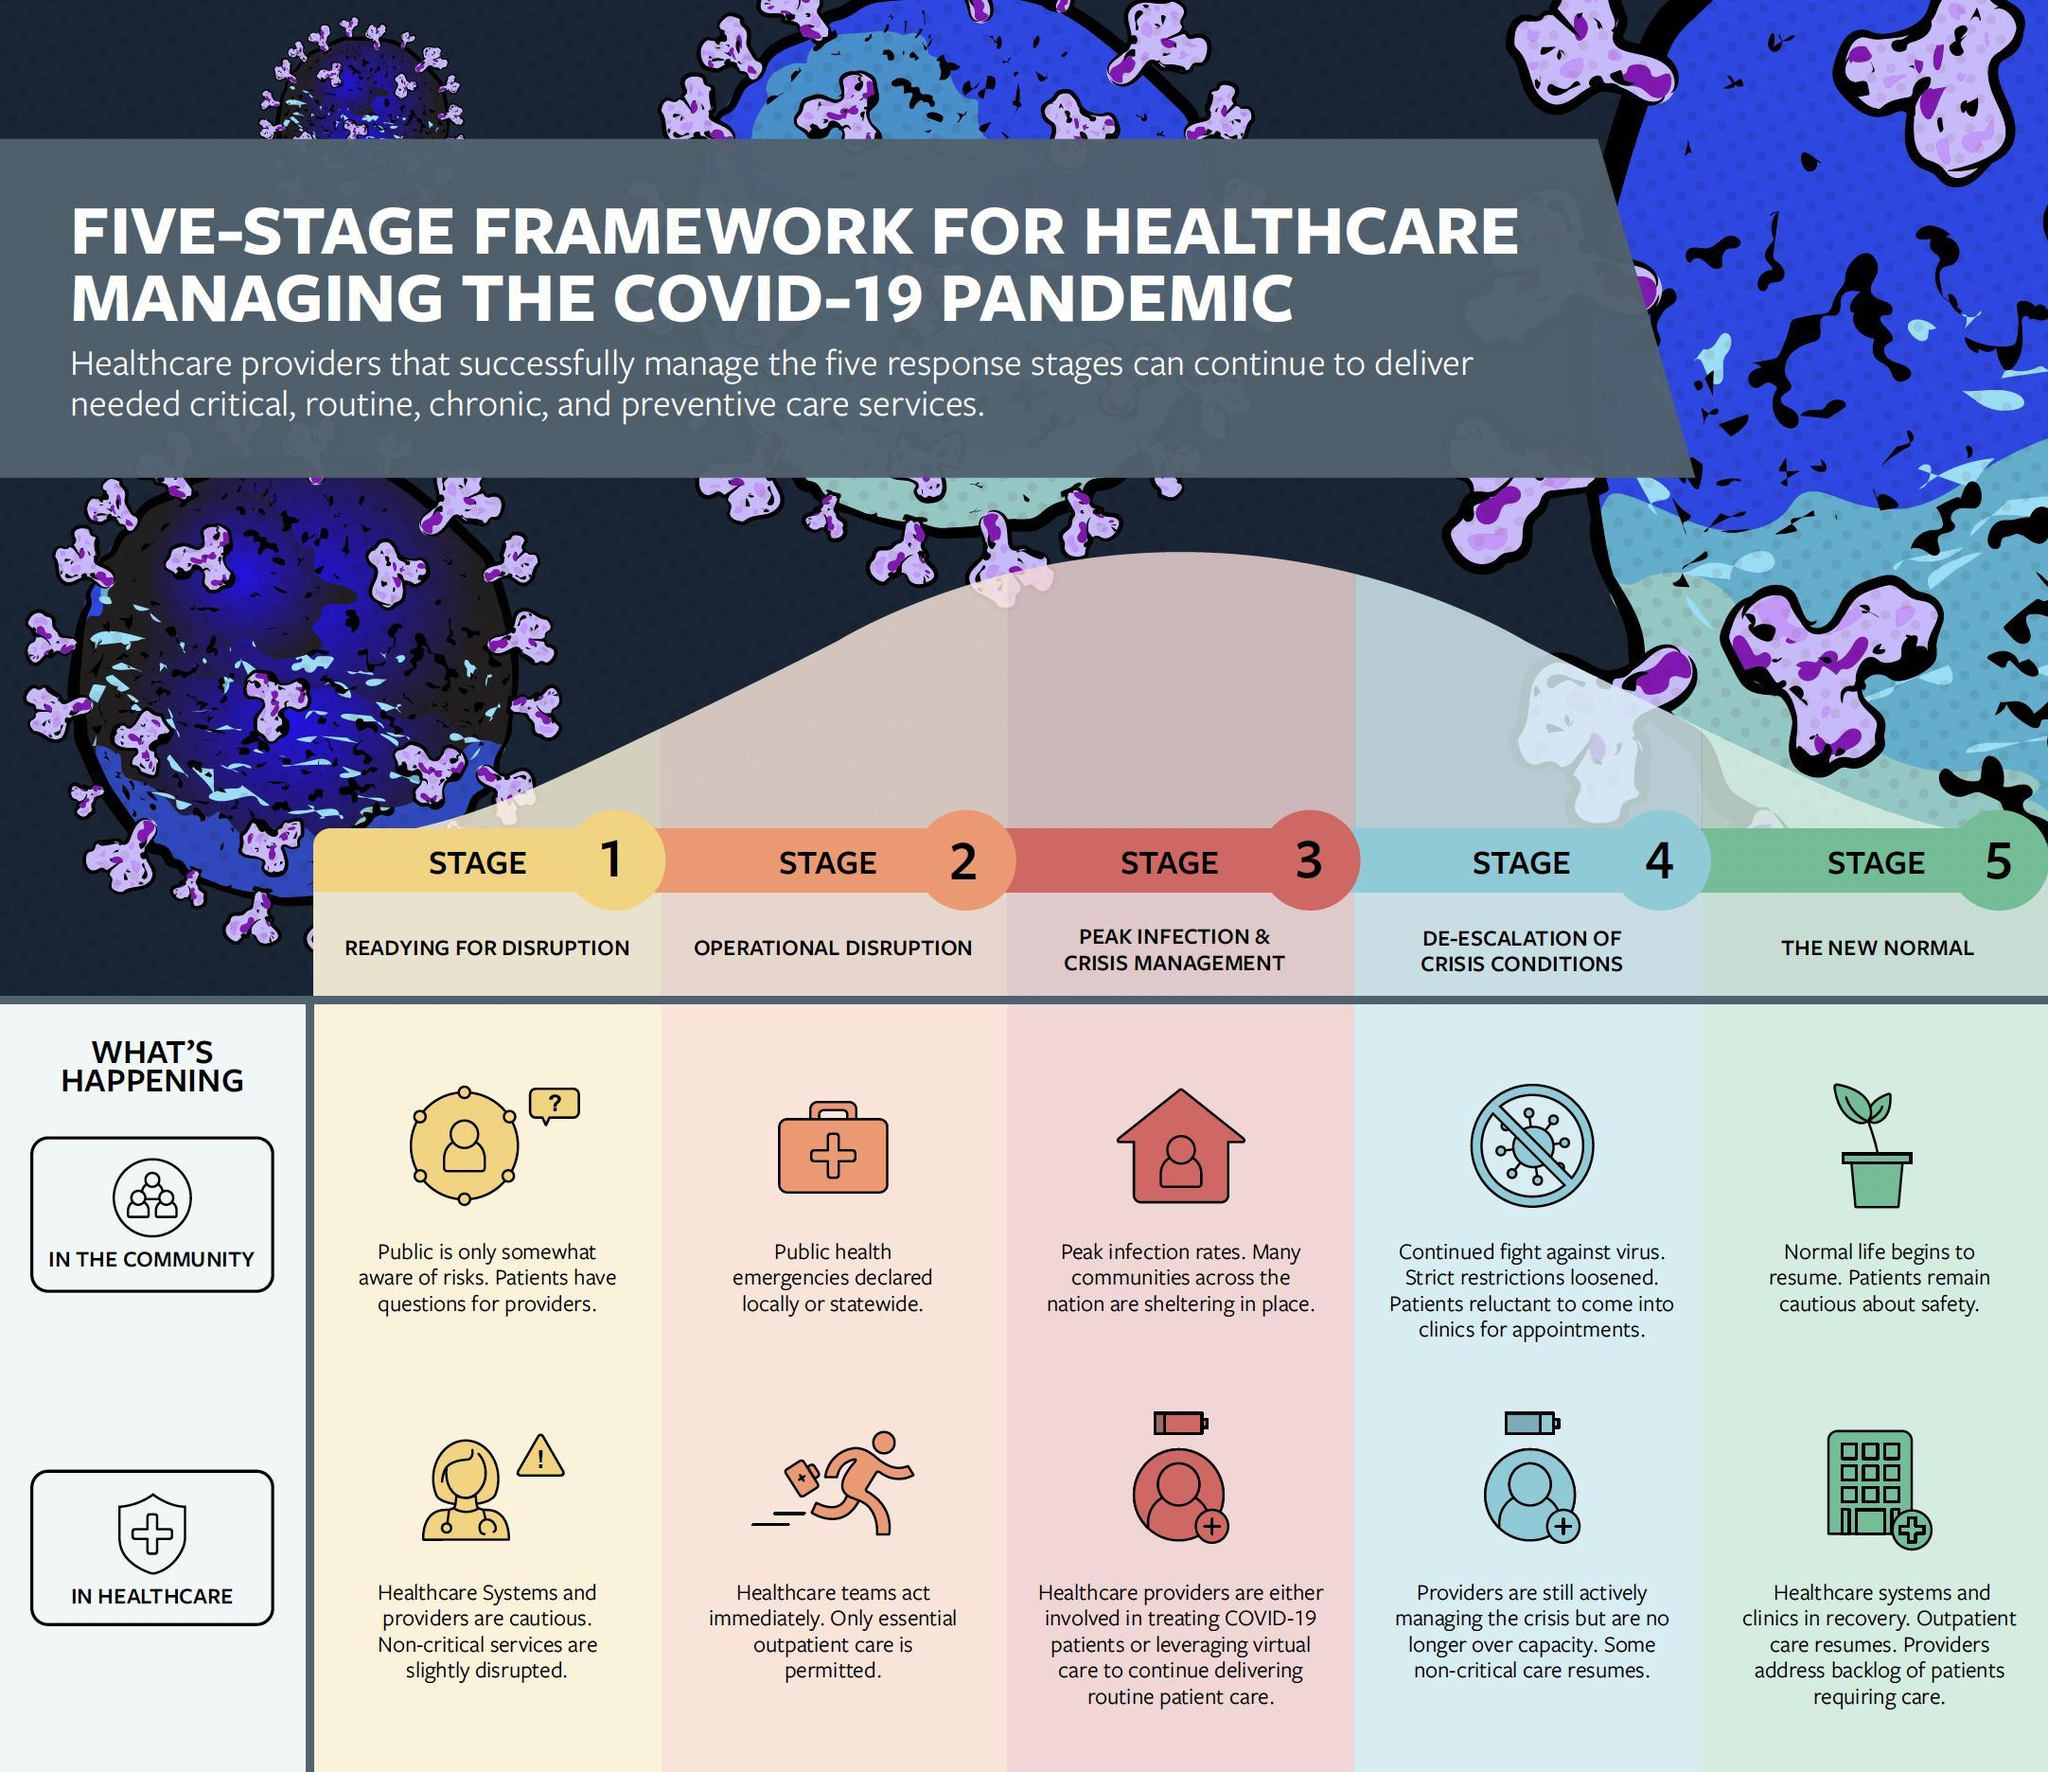In which stage is some of the non-critical care resumed in the healthcare?
Answer the question with a short phrase. Stage 4 What are the first two response stages in the framework of healthcare management? Readying for disruption, operational disruption In which stage are healthcare providers leveraging virtual care? Stage 4 In which stage is out patient care resumed in healthcare? Stage 5 In which stage is the patient community  reluctant to come to the clinics? Stage 4 What is the fifth response stage in the framework of healthcare management? The New normal In which response stage does normal life continue to resume in the community? Stage 5 Which are the two segments whose response stages are shown here? Community, health care In which stage are the public not fully aware of the risks? Stage 1 In which stage was public health emergencies declared locally or statewide? Stage 2 What is fourth response stage? De-escalation of crisis conditions 